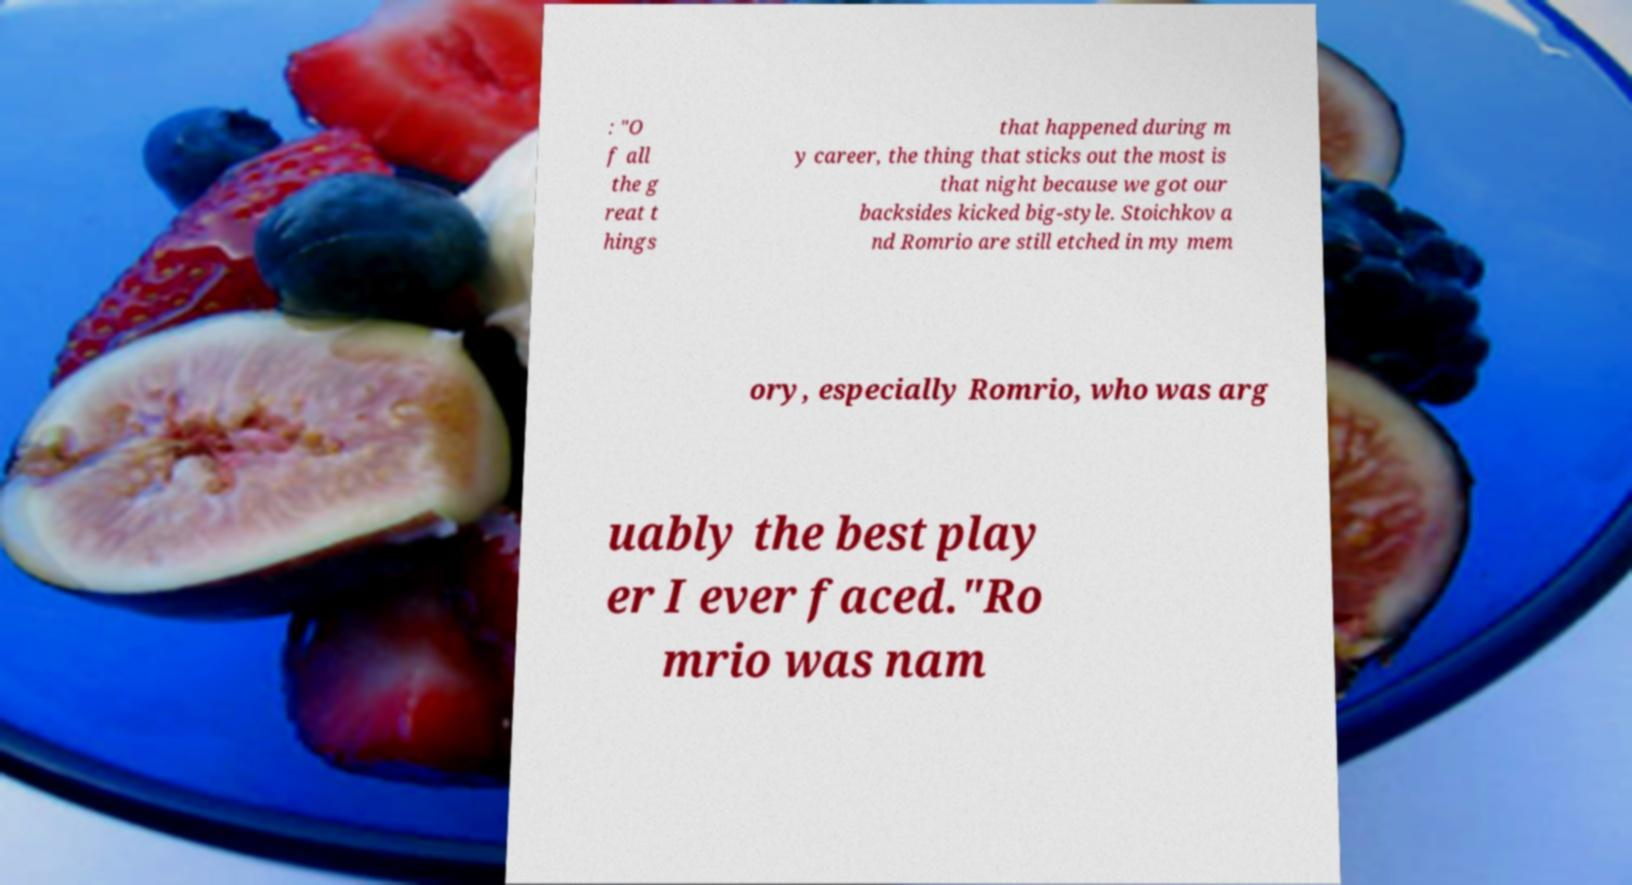Could you assist in decoding the text presented in this image and type it out clearly? : "O f all the g reat t hings that happened during m y career, the thing that sticks out the most is that night because we got our backsides kicked big-style. Stoichkov a nd Romrio are still etched in my mem ory, especially Romrio, who was arg uably the best play er I ever faced."Ro mrio was nam 